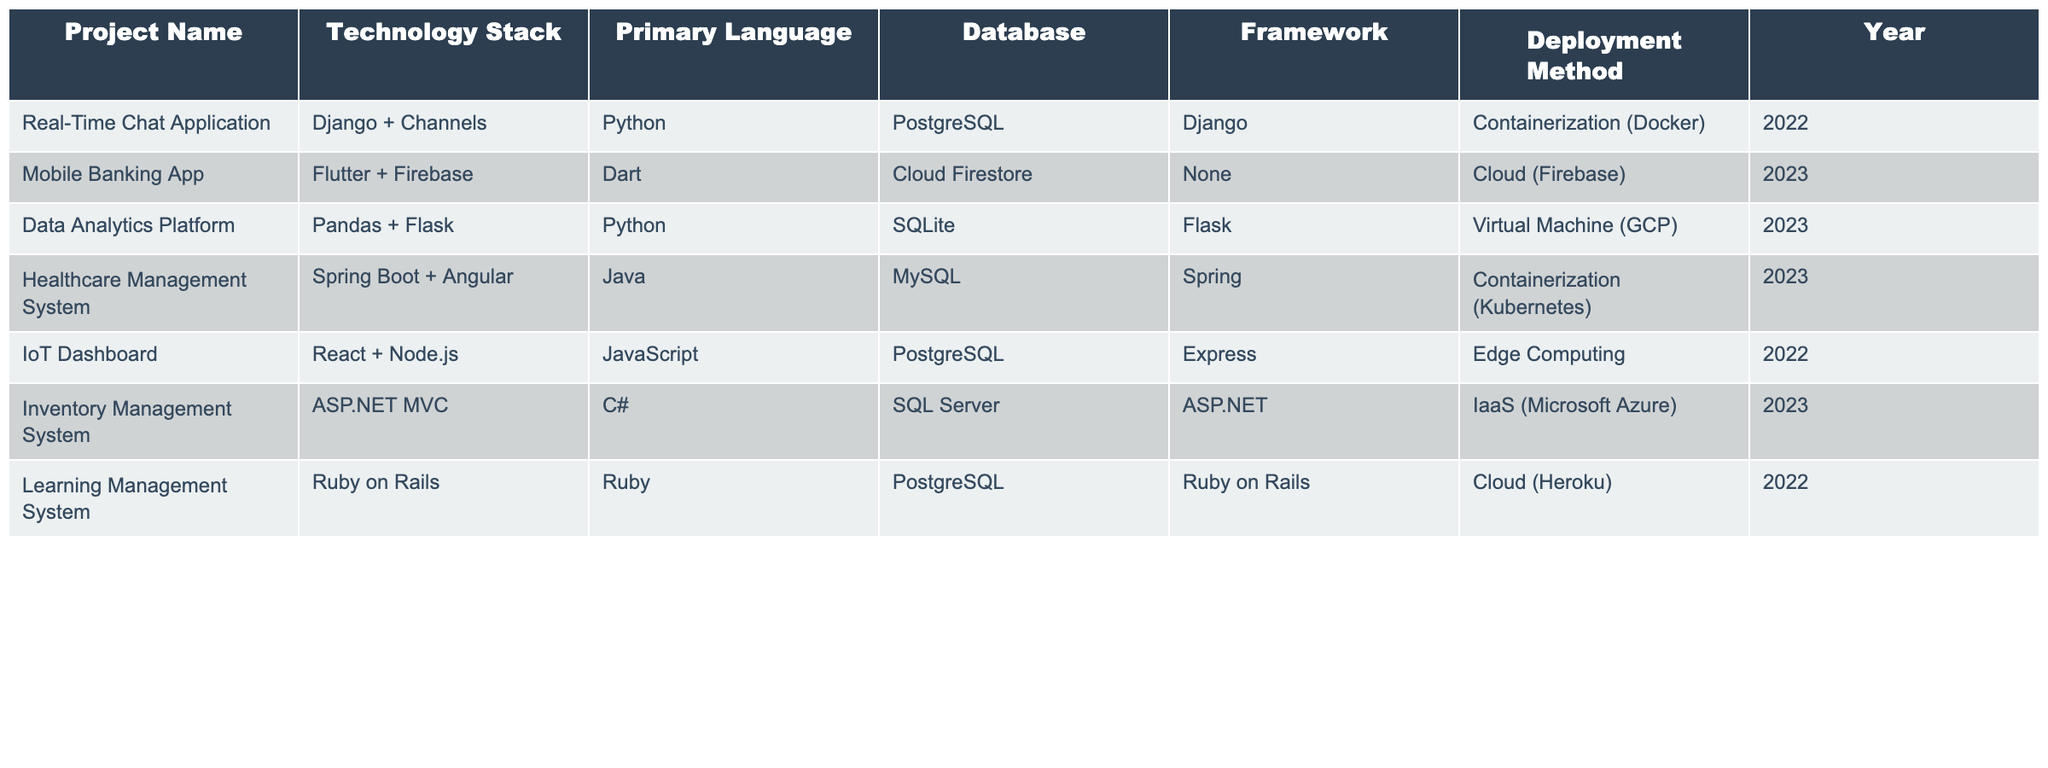What technology stack was used in the Healthcare Management System? The table lists the technology stack as "Spring Boot + Angular" for the project named "Healthcare Management System."
Answer: Spring Boot + Angular Which project uses Dart as its primary language? According to the table, the "Mobile Banking App" is the project that uses Dart.
Answer: Mobile Banking App How many projects were deployed using containerization? The table shows that there are two projects, "Real-Time Chat Application" and "Healthcare Management System," that used containerization methods.
Answer: 2 List the primary languages used in projects deployed in 2023. In the table, the primary languages for projects in 2023 are Dart (Mobile Banking App), Python (Data Analytics Platform), and Java (Healthcare Management System).
Answer: Dart, Python, Java Is there any project that uses PostgreSQL as its database? Yes, the "Real-Time Chat Application" and "IoT Dashboard" both use PostgreSQL as their database.
Answer: Yes What is the most recent year in which a project was deployed using Edge Computing? The table indicates that the IoT Dashboard was deployed in 2022, which is the most recent year for this deployment method.
Answer: 2022 How many projects utilize Flask as a framework in 2023? The table shows that there is only one project, the "Data Analytics Platform," that uses Flask as a framework in 2023.
Answer: 1 Which deployment method is used in the Mobile Banking App? The Mobile Banking App is deployed using the Cloud (Firebase) method based on the table's information.
Answer: Cloud (Firebase) What is the average number of years since the projects were completed, for those listed in the year 2023? The years for the 2023 projects are 2023, and they have all been completed in the same year, thus the average is (2023) = 2023.
Answer: 2023 Which project has the longest technology stack name? The project "Healthcare Management System" has the longest technology stack name: "Spring Boot + Angular."
Answer: Healthcare Management System 